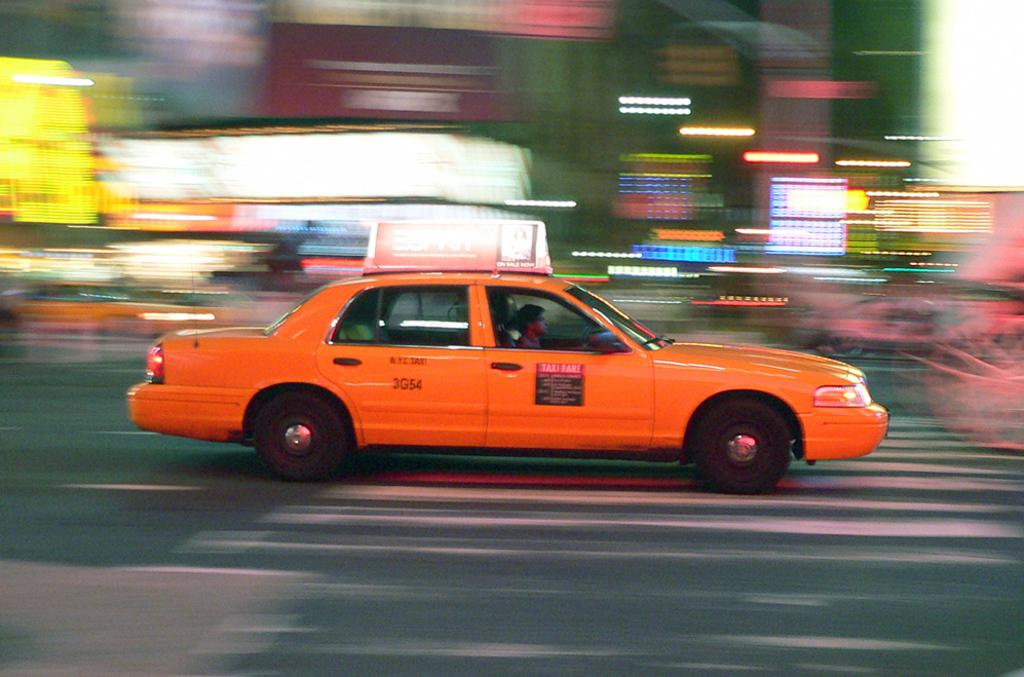<image>
Give a short and clear explanation of the subsequent image. Orange taxi cab that says the words "Taxi Fare" in red. 